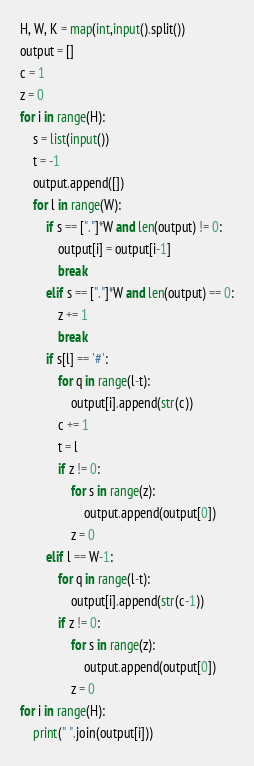Convert code to text. <code><loc_0><loc_0><loc_500><loc_500><_Python_>H, W, K = map(int,input().split())
output = []
c = 1
z = 0
for i in range(H):
    s = list(input())
    t = -1
    output.append([])
    for l in range(W):
        if s == ["."]*W and len(output) != 0:
            output[i] = output[i-1]
            break
        elif s == ["."]*W and len(output) == 0:
            z += 1
            break
        if s[l] == '#':
            for q in range(l-t):
                output[i].append(str(c))
            c += 1
            t = l
            if z != 0:
                for s in range(z):
                    output.append(output[0])
                z = 0
        elif l == W-1:
            for q in range(l-t):
                output[i].append(str(c-1))
            if z != 0:
                for s in range(z):
                    output.append(output[0])
                z = 0
for i in range(H):
    print(" ".join(output[i]))

</code> 